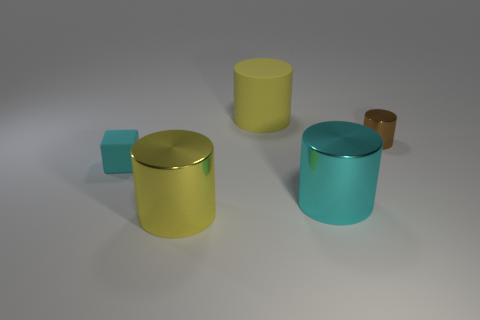Subtract all big brown metal things. Subtract all rubber objects. How many objects are left? 3 Add 4 big metallic things. How many big metallic things are left? 6 Add 3 brown cylinders. How many brown cylinders exist? 4 Add 2 tiny matte things. How many objects exist? 7 Subtract all yellow cylinders. How many cylinders are left? 2 Subtract all large cylinders. How many cylinders are left? 1 Subtract 0 red cylinders. How many objects are left? 5 Subtract all blocks. How many objects are left? 4 Subtract 1 cylinders. How many cylinders are left? 3 Subtract all purple blocks. Subtract all gray cylinders. How many blocks are left? 1 